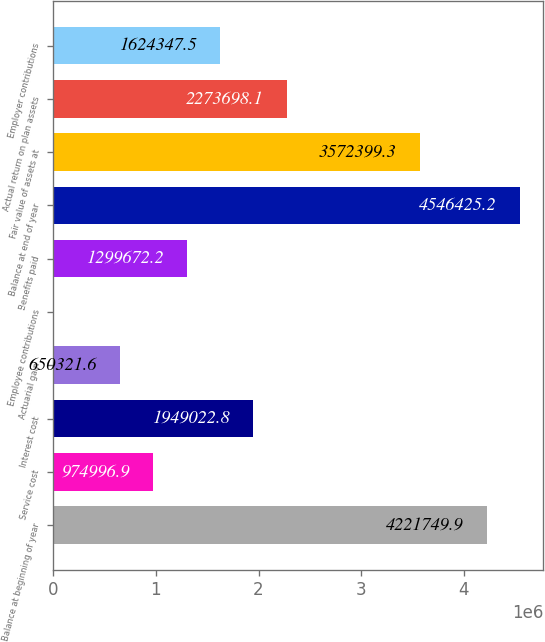Convert chart to OTSL. <chart><loc_0><loc_0><loc_500><loc_500><bar_chart><fcel>Balance at beginning of year<fcel>Service cost<fcel>Interest cost<fcel>Actuarial gain<fcel>Employee contributions<fcel>Benefits paid<fcel>Balance at end of year<fcel>Fair value of assets at<fcel>Actual return on plan assets<fcel>Employer contributions<nl><fcel>4.22175e+06<fcel>974997<fcel>1.94902e+06<fcel>650322<fcel>971<fcel>1.29967e+06<fcel>4.54643e+06<fcel>3.5724e+06<fcel>2.2737e+06<fcel>1.62435e+06<nl></chart> 